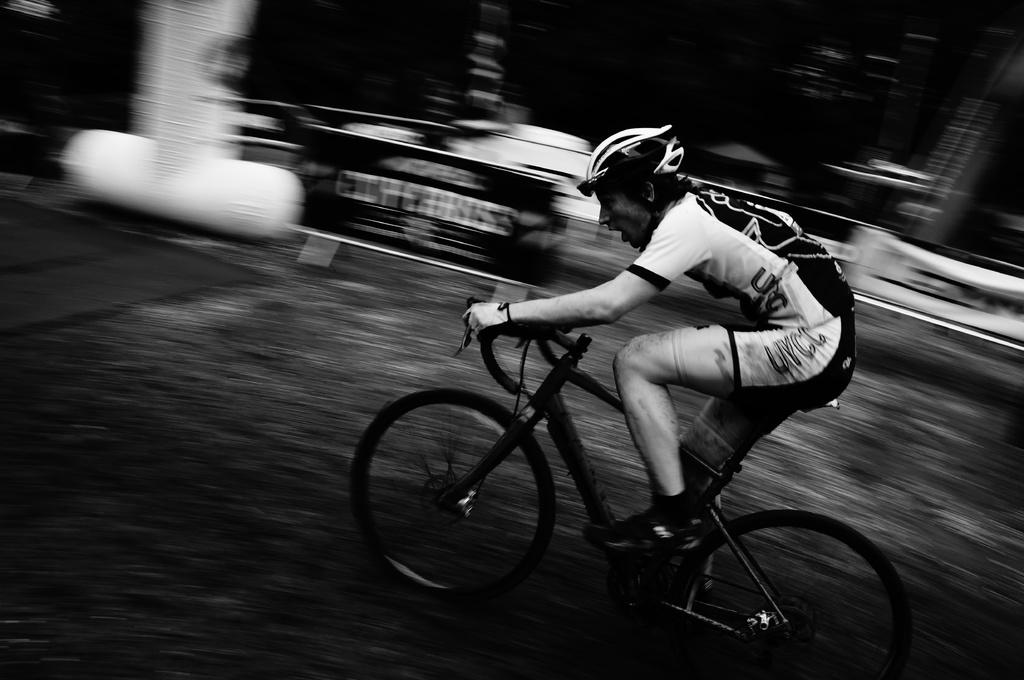Who is the main subject in the image? There is a man in the image. What is the man doing in the image? The man is on a cycle. Where is the man located in the image? The man is on a path. Can you describe the background of the image? The background of the image is blurred. What type of balls can be seen hanging from the cable in the image? There is no cable or balls present in the image; it features a man on a cycle on a path with a blurred background. 